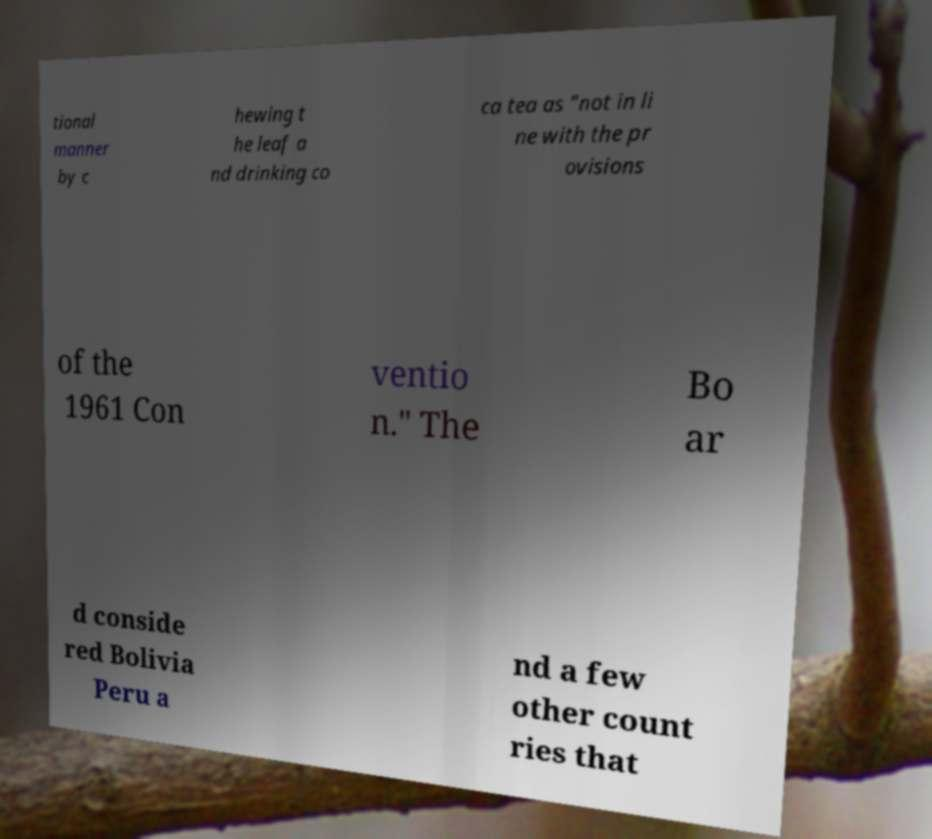What messages or text are displayed in this image? I need them in a readable, typed format. tional manner by c hewing t he leaf a nd drinking co ca tea as "not in li ne with the pr ovisions of the 1961 Con ventio n." The Bo ar d conside red Bolivia Peru a nd a few other count ries that 